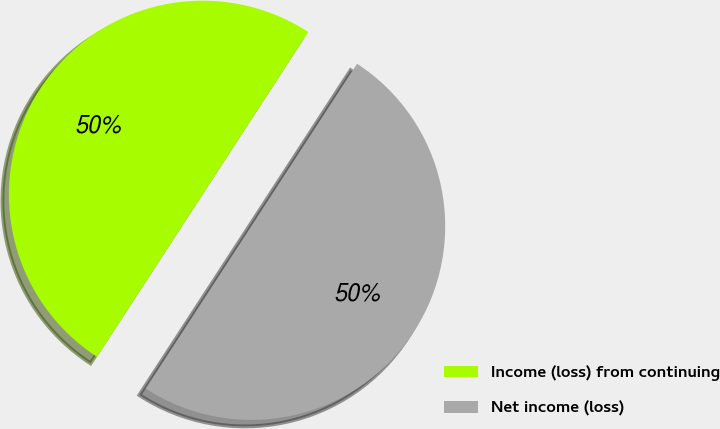Convert chart to OTSL. <chart><loc_0><loc_0><loc_500><loc_500><pie_chart><fcel>Income (loss) from continuing<fcel>Net income (loss)<nl><fcel>50.0%<fcel>50.0%<nl></chart> 